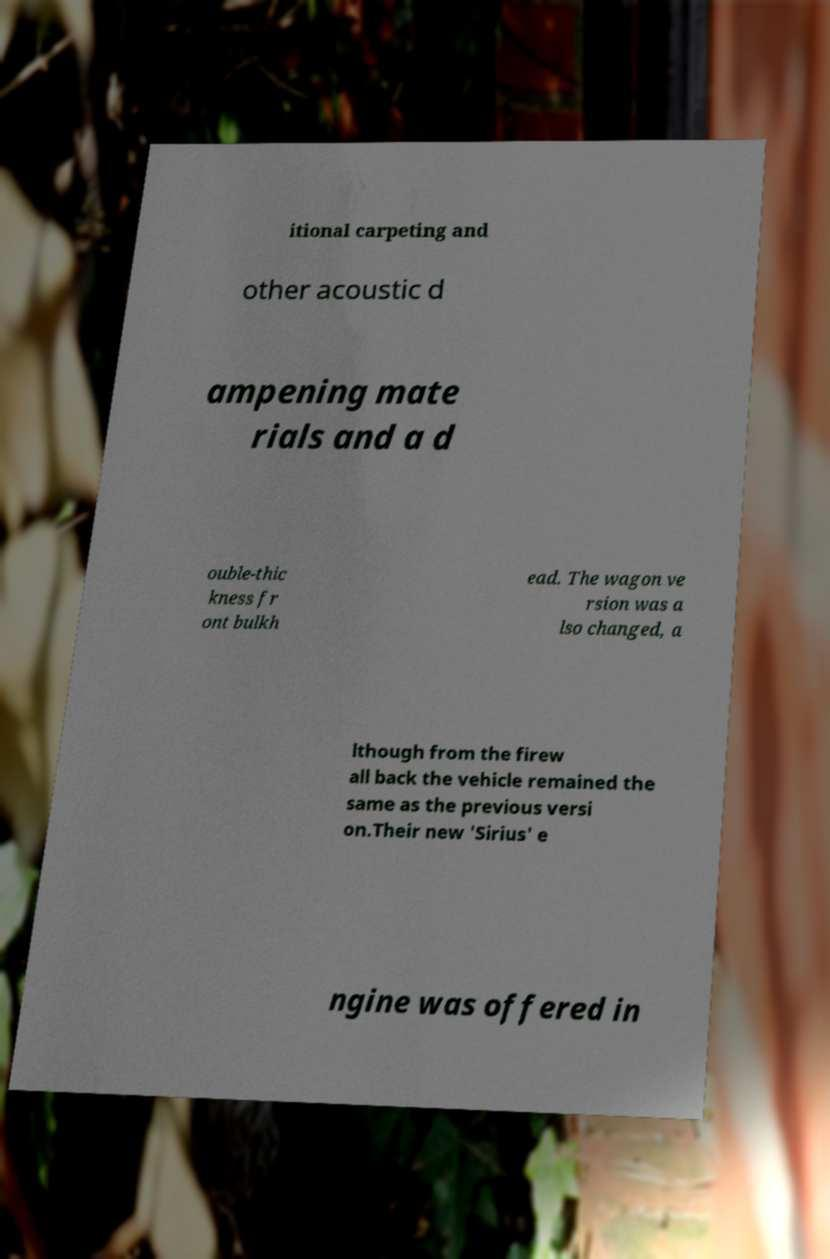Can you accurately transcribe the text from the provided image for me? itional carpeting and other acoustic d ampening mate rials and a d ouble-thic kness fr ont bulkh ead. The wagon ve rsion was a lso changed, a lthough from the firew all back the vehicle remained the same as the previous versi on.Their new 'Sirius' e ngine was offered in 